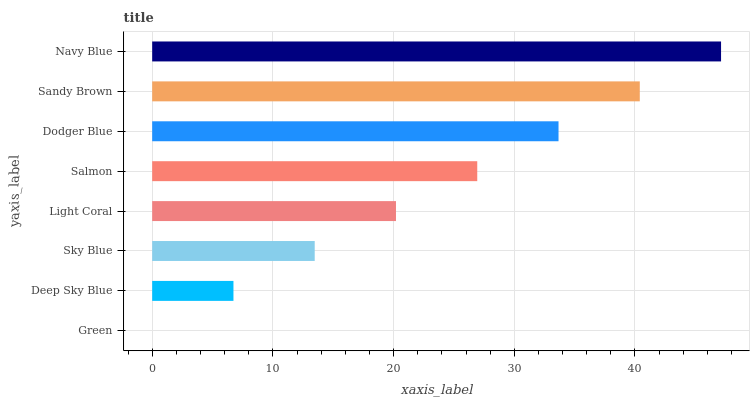Is Green the minimum?
Answer yes or no. Yes. Is Navy Blue the maximum?
Answer yes or no. Yes. Is Deep Sky Blue the minimum?
Answer yes or no. No. Is Deep Sky Blue the maximum?
Answer yes or no. No. Is Deep Sky Blue greater than Green?
Answer yes or no. Yes. Is Green less than Deep Sky Blue?
Answer yes or no. Yes. Is Green greater than Deep Sky Blue?
Answer yes or no. No. Is Deep Sky Blue less than Green?
Answer yes or no. No. Is Salmon the high median?
Answer yes or no. Yes. Is Light Coral the low median?
Answer yes or no. Yes. Is Sky Blue the high median?
Answer yes or no. No. Is Dodger Blue the low median?
Answer yes or no. No. 